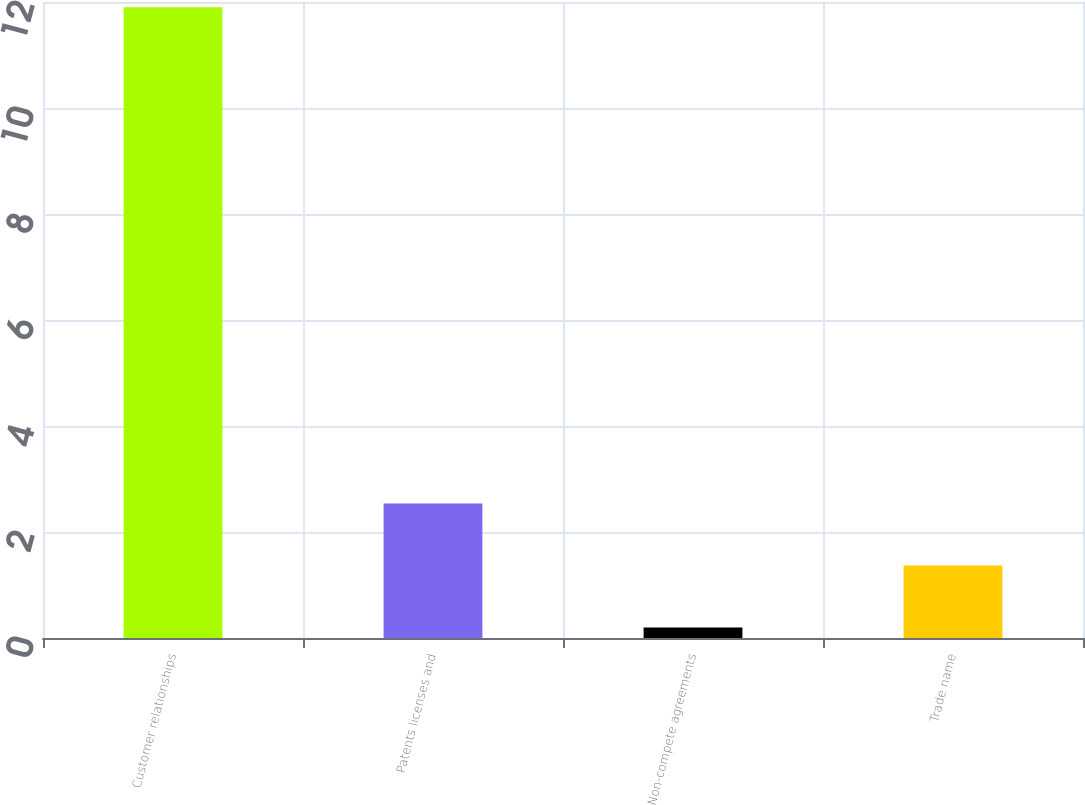Convert chart. <chart><loc_0><loc_0><loc_500><loc_500><bar_chart><fcel>Customer relationships<fcel>Patents licenses and<fcel>Non-compete agreements<fcel>Trade name<nl><fcel>11.9<fcel>2.54<fcel>0.2<fcel>1.37<nl></chart> 